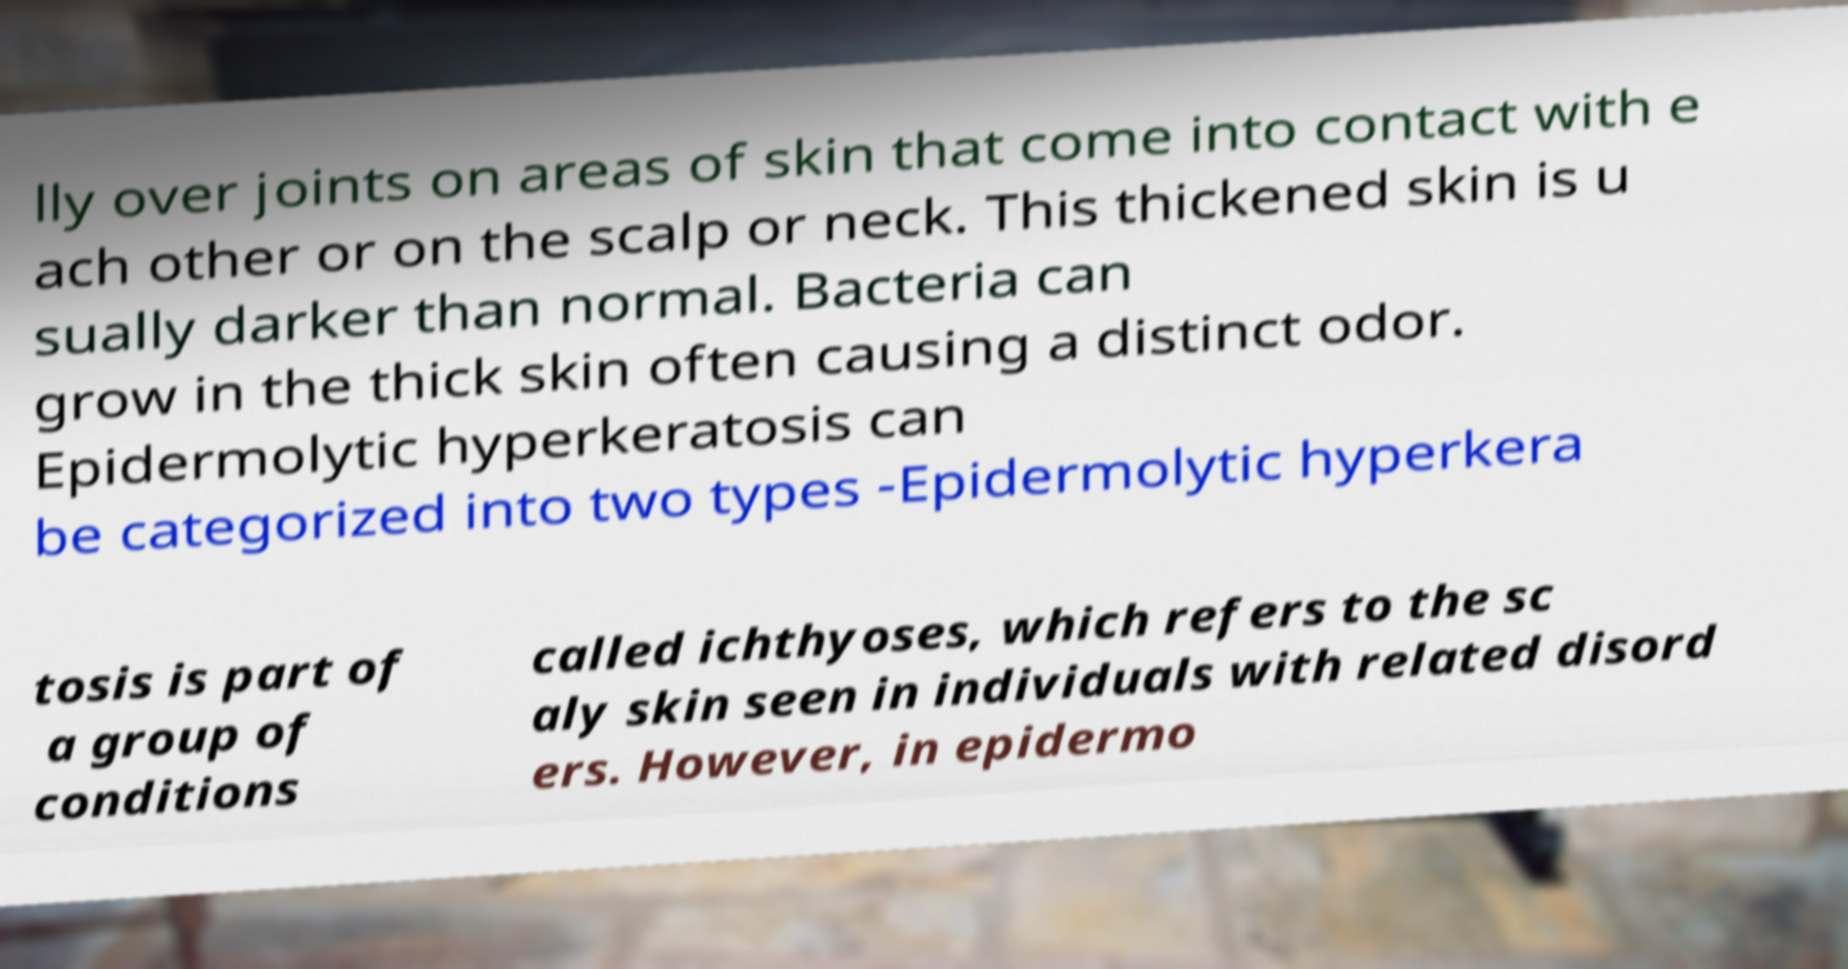Please read and relay the text visible in this image. What does it say? lly over joints on areas of skin that come into contact with e ach other or on the scalp or neck. This thickened skin is u sually darker than normal. Bacteria can grow in the thick skin often causing a distinct odor. Epidermolytic hyperkeratosis can be categorized into two types -Epidermolytic hyperkera tosis is part of a group of conditions called ichthyoses, which refers to the sc aly skin seen in individuals with related disord ers. However, in epidermo 